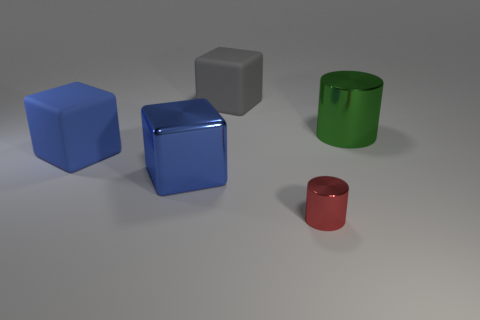There is a large green thing that is the same shape as the small thing; what material is it? The large green object, similar in shape to the smaller one, appears to be made of a smooth, reflective material, suggestive of polished metal, potentially stainless steel or painted metal, due to its high-gloss finish. 